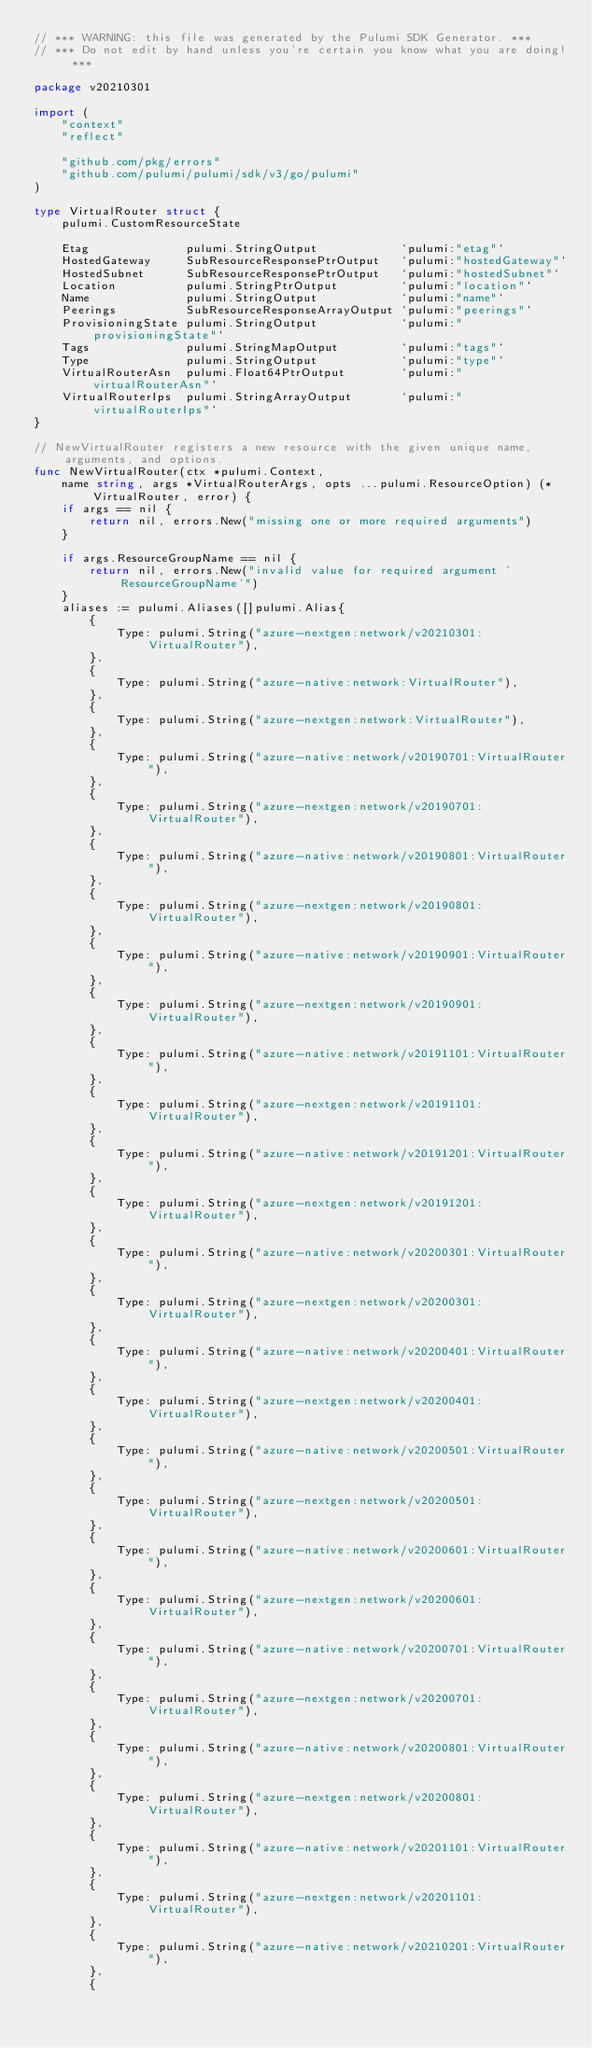<code> <loc_0><loc_0><loc_500><loc_500><_Go_>// *** WARNING: this file was generated by the Pulumi SDK Generator. ***
// *** Do not edit by hand unless you're certain you know what you are doing! ***

package v20210301

import (
	"context"
	"reflect"

	"github.com/pkg/errors"
	"github.com/pulumi/pulumi/sdk/v3/go/pulumi"
)

type VirtualRouter struct {
	pulumi.CustomResourceState

	Etag              pulumi.StringOutput            `pulumi:"etag"`
	HostedGateway     SubResourceResponsePtrOutput   `pulumi:"hostedGateway"`
	HostedSubnet      SubResourceResponsePtrOutput   `pulumi:"hostedSubnet"`
	Location          pulumi.StringPtrOutput         `pulumi:"location"`
	Name              pulumi.StringOutput            `pulumi:"name"`
	Peerings          SubResourceResponseArrayOutput `pulumi:"peerings"`
	ProvisioningState pulumi.StringOutput            `pulumi:"provisioningState"`
	Tags              pulumi.StringMapOutput         `pulumi:"tags"`
	Type              pulumi.StringOutput            `pulumi:"type"`
	VirtualRouterAsn  pulumi.Float64PtrOutput        `pulumi:"virtualRouterAsn"`
	VirtualRouterIps  pulumi.StringArrayOutput       `pulumi:"virtualRouterIps"`
}

// NewVirtualRouter registers a new resource with the given unique name, arguments, and options.
func NewVirtualRouter(ctx *pulumi.Context,
	name string, args *VirtualRouterArgs, opts ...pulumi.ResourceOption) (*VirtualRouter, error) {
	if args == nil {
		return nil, errors.New("missing one or more required arguments")
	}

	if args.ResourceGroupName == nil {
		return nil, errors.New("invalid value for required argument 'ResourceGroupName'")
	}
	aliases := pulumi.Aliases([]pulumi.Alias{
		{
			Type: pulumi.String("azure-nextgen:network/v20210301:VirtualRouter"),
		},
		{
			Type: pulumi.String("azure-native:network:VirtualRouter"),
		},
		{
			Type: pulumi.String("azure-nextgen:network:VirtualRouter"),
		},
		{
			Type: pulumi.String("azure-native:network/v20190701:VirtualRouter"),
		},
		{
			Type: pulumi.String("azure-nextgen:network/v20190701:VirtualRouter"),
		},
		{
			Type: pulumi.String("azure-native:network/v20190801:VirtualRouter"),
		},
		{
			Type: pulumi.String("azure-nextgen:network/v20190801:VirtualRouter"),
		},
		{
			Type: pulumi.String("azure-native:network/v20190901:VirtualRouter"),
		},
		{
			Type: pulumi.String("azure-nextgen:network/v20190901:VirtualRouter"),
		},
		{
			Type: pulumi.String("azure-native:network/v20191101:VirtualRouter"),
		},
		{
			Type: pulumi.String("azure-nextgen:network/v20191101:VirtualRouter"),
		},
		{
			Type: pulumi.String("azure-native:network/v20191201:VirtualRouter"),
		},
		{
			Type: pulumi.String("azure-nextgen:network/v20191201:VirtualRouter"),
		},
		{
			Type: pulumi.String("azure-native:network/v20200301:VirtualRouter"),
		},
		{
			Type: pulumi.String("azure-nextgen:network/v20200301:VirtualRouter"),
		},
		{
			Type: pulumi.String("azure-native:network/v20200401:VirtualRouter"),
		},
		{
			Type: pulumi.String("azure-nextgen:network/v20200401:VirtualRouter"),
		},
		{
			Type: pulumi.String("azure-native:network/v20200501:VirtualRouter"),
		},
		{
			Type: pulumi.String("azure-nextgen:network/v20200501:VirtualRouter"),
		},
		{
			Type: pulumi.String("azure-native:network/v20200601:VirtualRouter"),
		},
		{
			Type: pulumi.String("azure-nextgen:network/v20200601:VirtualRouter"),
		},
		{
			Type: pulumi.String("azure-native:network/v20200701:VirtualRouter"),
		},
		{
			Type: pulumi.String("azure-nextgen:network/v20200701:VirtualRouter"),
		},
		{
			Type: pulumi.String("azure-native:network/v20200801:VirtualRouter"),
		},
		{
			Type: pulumi.String("azure-nextgen:network/v20200801:VirtualRouter"),
		},
		{
			Type: pulumi.String("azure-native:network/v20201101:VirtualRouter"),
		},
		{
			Type: pulumi.String("azure-nextgen:network/v20201101:VirtualRouter"),
		},
		{
			Type: pulumi.String("azure-native:network/v20210201:VirtualRouter"),
		},
		{</code> 